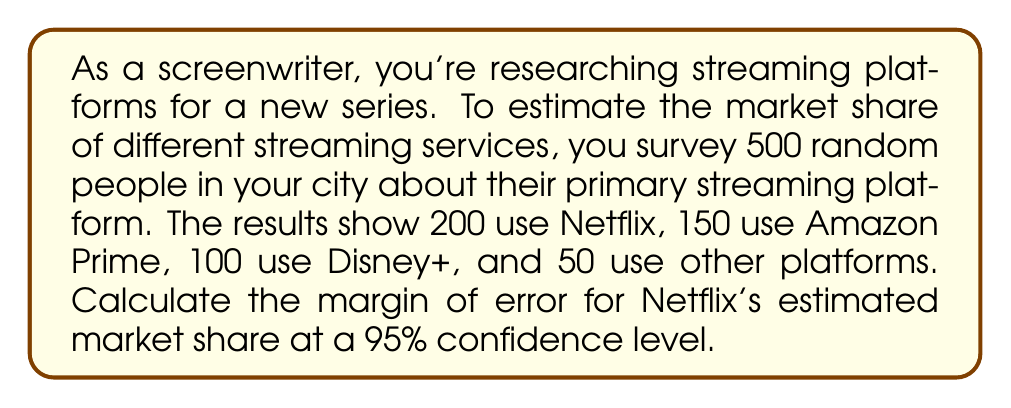Solve this math problem. To calculate the margin of error for Netflix's estimated market share, we'll follow these steps:

1. Calculate the sample proportion (p):
   $p = \frac{\text{Number of Netflix users}}{\text{Total sample size}} = \frac{200}{500} = 0.4$

2. Calculate the standard error (SE):
   $SE = \sqrt{\frac{p(1-p)}{n}}$
   Where n is the sample size.
   $SE = \sqrt{\frac{0.4(1-0.4)}{500}} = \sqrt{\frac{0.24}{500}} = 0.0219$

3. For a 95% confidence level, use the z-score of 1.96.

4. Calculate the margin of error (MOE):
   $MOE = z \times SE$
   $MOE = 1.96 \times 0.0219 = 0.0429$

5. Convert to percentage:
   $0.0429 \times 100 = 4.29\%$

Therefore, the margin of error for Netflix's estimated market share is approximately 4.29% at a 95% confidence level.
Answer: 4.29% 